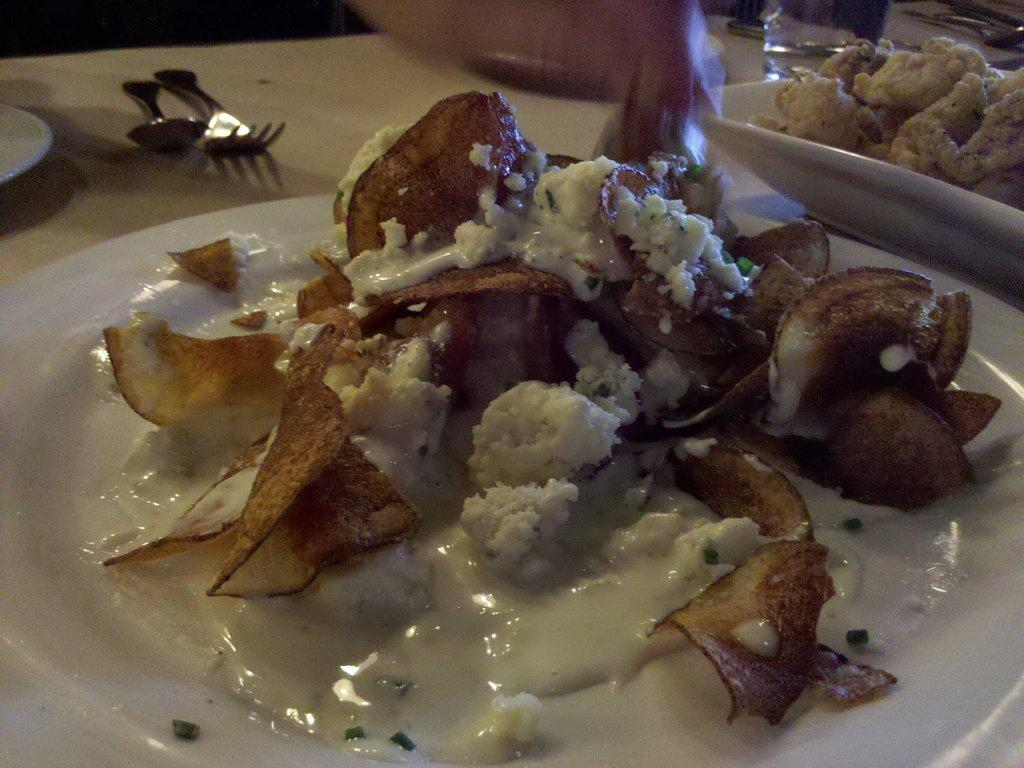What type of utensils can be seen in the image? There are spoons and a fork in the image. What else is present in the image besides utensils? There are plates and a glass in the image. What is on the plates in the image? Different types of food are present on the plates. Can you tell me how many people are talking on the hill in the image? There is no hill or people talking in the image; it only features plates, spoons, a fork, a glass, and food on the plates. 